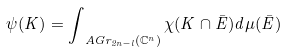Convert formula to latex. <formula><loc_0><loc_0><loc_500><loc_500>\psi ( K ) = \int _ { \ A G r _ { 2 n - l } ( \mathbb { C } ^ { n } ) } \chi ( K \cap \bar { E } ) d \mu ( \bar { E } )</formula> 